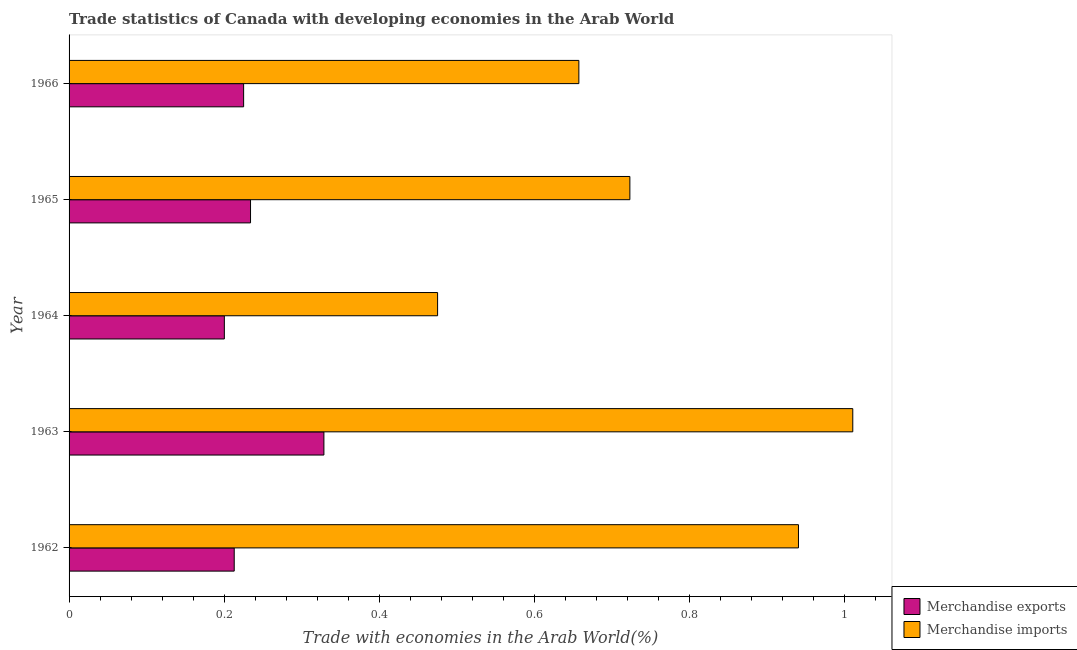How many different coloured bars are there?
Offer a very short reply. 2. Are the number of bars per tick equal to the number of legend labels?
Ensure brevity in your answer.  Yes. How many bars are there on the 2nd tick from the bottom?
Give a very brief answer. 2. What is the label of the 3rd group of bars from the top?
Ensure brevity in your answer.  1964. In how many cases, is the number of bars for a given year not equal to the number of legend labels?
Offer a terse response. 0. What is the merchandise exports in 1964?
Your answer should be very brief. 0.2. Across all years, what is the maximum merchandise imports?
Ensure brevity in your answer.  1.01. Across all years, what is the minimum merchandise exports?
Your response must be concise. 0.2. In which year was the merchandise exports minimum?
Your response must be concise. 1964. What is the total merchandise exports in the graph?
Your response must be concise. 1.2. What is the difference between the merchandise exports in 1964 and that in 1965?
Your answer should be very brief. -0.03. What is the difference between the merchandise exports in 1963 and the merchandise imports in 1965?
Offer a very short reply. -0.39. What is the average merchandise imports per year?
Your answer should be very brief. 0.76. In the year 1963, what is the difference between the merchandise exports and merchandise imports?
Ensure brevity in your answer.  -0.68. In how many years, is the merchandise exports greater than 0.48000000000000004 %?
Keep it short and to the point. 0. What is the ratio of the merchandise exports in 1964 to that in 1965?
Offer a terse response. 0.86. What is the difference between the highest and the second highest merchandise exports?
Your answer should be compact. 0.1. What is the difference between the highest and the lowest merchandise exports?
Keep it short and to the point. 0.13. In how many years, is the merchandise exports greater than the average merchandise exports taken over all years?
Your answer should be very brief. 1. What does the 2nd bar from the bottom in 1962 represents?
Make the answer very short. Merchandise imports. What is the difference between two consecutive major ticks on the X-axis?
Your response must be concise. 0.2. Are the values on the major ticks of X-axis written in scientific E-notation?
Give a very brief answer. No. What is the title of the graph?
Provide a short and direct response. Trade statistics of Canada with developing economies in the Arab World. Does "Food and tobacco" appear as one of the legend labels in the graph?
Offer a terse response. No. What is the label or title of the X-axis?
Ensure brevity in your answer.  Trade with economies in the Arab World(%). What is the label or title of the Y-axis?
Offer a terse response. Year. What is the Trade with economies in the Arab World(%) of Merchandise exports in 1962?
Make the answer very short. 0.21. What is the Trade with economies in the Arab World(%) of Merchandise imports in 1962?
Offer a terse response. 0.94. What is the Trade with economies in the Arab World(%) in Merchandise exports in 1963?
Provide a short and direct response. 0.33. What is the Trade with economies in the Arab World(%) in Merchandise imports in 1963?
Offer a very short reply. 1.01. What is the Trade with economies in the Arab World(%) of Merchandise exports in 1964?
Provide a succinct answer. 0.2. What is the Trade with economies in the Arab World(%) in Merchandise imports in 1964?
Provide a short and direct response. 0.48. What is the Trade with economies in the Arab World(%) in Merchandise exports in 1965?
Keep it short and to the point. 0.23. What is the Trade with economies in the Arab World(%) of Merchandise imports in 1965?
Your answer should be compact. 0.72. What is the Trade with economies in the Arab World(%) of Merchandise exports in 1966?
Your answer should be very brief. 0.23. What is the Trade with economies in the Arab World(%) in Merchandise imports in 1966?
Ensure brevity in your answer.  0.66. Across all years, what is the maximum Trade with economies in the Arab World(%) in Merchandise exports?
Keep it short and to the point. 0.33. Across all years, what is the maximum Trade with economies in the Arab World(%) in Merchandise imports?
Your answer should be compact. 1.01. Across all years, what is the minimum Trade with economies in the Arab World(%) in Merchandise exports?
Keep it short and to the point. 0.2. Across all years, what is the minimum Trade with economies in the Arab World(%) in Merchandise imports?
Provide a succinct answer. 0.48. What is the total Trade with economies in the Arab World(%) in Merchandise exports in the graph?
Your response must be concise. 1.2. What is the total Trade with economies in the Arab World(%) of Merchandise imports in the graph?
Your response must be concise. 3.81. What is the difference between the Trade with economies in the Arab World(%) of Merchandise exports in 1962 and that in 1963?
Give a very brief answer. -0.12. What is the difference between the Trade with economies in the Arab World(%) in Merchandise imports in 1962 and that in 1963?
Keep it short and to the point. -0.07. What is the difference between the Trade with economies in the Arab World(%) of Merchandise exports in 1962 and that in 1964?
Make the answer very short. 0.01. What is the difference between the Trade with economies in the Arab World(%) in Merchandise imports in 1962 and that in 1964?
Offer a very short reply. 0.47. What is the difference between the Trade with economies in the Arab World(%) of Merchandise exports in 1962 and that in 1965?
Your response must be concise. -0.02. What is the difference between the Trade with economies in the Arab World(%) in Merchandise imports in 1962 and that in 1965?
Give a very brief answer. 0.22. What is the difference between the Trade with economies in the Arab World(%) of Merchandise exports in 1962 and that in 1966?
Give a very brief answer. -0.01. What is the difference between the Trade with economies in the Arab World(%) in Merchandise imports in 1962 and that in 1966?
Your response must be concise. 0.28. What is the difference between the Trade with economies in the Arab World(%) in Merchandise exports in 1963 and that in 1964?
Your answer should be compact. 0.13. What is the difference between the Trade with economies in the Arab World(%) of Merchandise imports in 1963 and that in 1964?
Ensure brevity in your answer.  0.54. What is the difference between the Trade with economies in the Arab World(%) in Merchandise exports in 1963 and that in 1965?
Offer a very short reply. 0.09. What is the difference between the Trade with economies in the Arab World(%) of Merchandise imports in 1963 and that in 1965?
Keep it short and to the point. 0.29. What is the difference between the Trade with economies in the Arab World(%) of Merchandise exports in 1963 and that in 1966?
Offer a terse response. 0.1. What is the difference between the Trade with economies in the Arab World(%) in Merchandise imports in 1963 and that in 1966?
Make the answer very short. 0.35. What is the difference between the Trade with economies in the Arab World(%) in Merchandise exports in 1964 and that in 1965?
Make the answer very short. -0.03. What is the difference between the Trade with economies in the Arab World(%) in Merchandise imports in 1964 and that in 1965?
Make the answer very short. -0.25. What is the difference between the Trade with economies in the Arab World(%) of Merchandise exports in 1964 and that in 1966?
Provide a short and direct response. -0.02. What is the difference between the Trade with economies in the Arab World(%) in Merchandise imports in 1964 and that in 1966?
Ensure brevity in your answer.  -0.18. What is the difference between the Trade with economies in the Arab World(%) in Merchandise exports in 1965 and that in 1966?
Offer a very short reply. 0.01. What is the difference between the Trade with economies in the Arab World(%) of Merchandise imports in 1965 and that in 1966?
Provide a short and direct response. 0.07. What is the difference between the Trade with economies in the Arab World(%) in Merchandise exports in 1962 and the Trade with economies in the Arab World(%) in Merchandise imports in 1963?
Offer a terse response. -0.8. What is the difference between the Trade with economies in the Arab World(%) of Merchandise exports in 1962 and the Trade with economies in the Arab World(%) of Merchandise imports in 1964?
Your response must be concise. -0.26. What is the difference between the Trade with economies in the Arab World(%) in Merchandise exports in 1962 and the Trade with economies in the Arab World(%) in Merchandise imports in 1965?
Ensure brevity in your answer.  -0.51. What is the difference between the Trade with economies in the Arab World(%) in Merchandise exports in 1962 and the Trade with economies in the Arab World(%) in Merchandise imports in 1966?
Your answer should be compact. -0.44. What is the difference between the Trade with economies in the Arab World(%) in Merchandise exports in 1963 and the Trade with economies in the Arab World(%) in Merchandise imports in 1964?
Give a very brief answer. -0.15. What is the difference between the Trade with economies in the Arab World(%) in Merchandise exports in 1963 and the Trade with economies in the Arab World(%) in Merchandise imports in 1965?
Ensure brevity in your answer.  -0.39. What is the difference between the Trade with economies in the Arab World(%) in Merchandise exports in 1963 and the Trade with economies in the Arab World(%) in Merchandise imports in 1966?
Your answer should be very brief. -0.33. What is the difference between the Trade with economies in the Arab World(%) in Merchandise exports in 1964 and the Trade with economies in the Arab World(%) in Merchandise imports in 1965?
Provide a succinct answer. -0.52. What is the difference between the Trade with economies in the Arab World(%) of Merchandise exports in 1964 and the Trade with economies in the Arab World(%) of Merchandise imports in 1966?
Offer a very short reply. -0.46. What is the difference between the Trade with economies in the Arab World(%) of Merchandise exports in 1965 and the Trade with economies in the Arab World(%) of Merchandise imports in 1966?
Provide a short and direct response. -0.42. What is the average Trade with economies in the Arab World(%) in Merchandise exports per year?
Offer a very short reply. 0.24. What is the average Trade with economies in the Arab World(%) in Merchandise imports per year?
Make the answer very short. 0.76. In the year 1962, what is the difference between the Trade with economies in the Arab World(%) in Merchandise exports and Trade with economies in the Arab World(%) in Merchandise imports?
Offer a very short reply. -0.73. In the year 1963, what is the difference between the Trade with economies in the Arab World(%) of Merchandise exports and Trade with economies in the Arab World(%) of Merchandise imports?
Your response must be concise. -0.68. In the year 1964, what is the difference between the Trade with economies in the Arab World(%) in Merchandise exports and Trade with economies in the Arab World(%) in Merchandise imports?
Your answer should be compact. -0.27. In the year 1965, what is the difference between the Trade with economies in the Arab World(%) of Merchandise exports and Trade with economies in the Arab World(%) of Merchandise imports?
Ensure brevity in your answer.  -0.49. In the year 1966, what is the difference between the Trade with economies in the Arab World(%) in Merchandise exports and Trade with economies in the Arab World(%) in Merchandise imports?
Provide a short and direct response. -0.43. What is the ratio of the Trade with economies in the Arab World(%) of Merchandise exports in 1962 to that in 1963?
Keep it short and to the point. 0.65. What is the ratio of the Trade with economies in the Arab World(%) of Merchandise imports in 1962 to that in 1963?
Provide a succinct answer. 0.93. What is the ratio of the Trade with economies in the Arab World(%) of Merchandise exports in 1962 to that in 1964?
Your answer should be compact. 1.06. What is the ratio of the Trade with economies in the Arab World(%) in Merchandise imports in 1962 to that in 1964?
Your response must be concise. 1.98. What is the ratio of the Trade with economies in the Arab World(%) of Merchandise exports in 1962 to that in 1965?
Give a very brief answer. 0.91. What is the ratio of the Trade with economies in the Arab World(%) in Merchandise imports in 1962 to that in 1965?
Offer a terse response. 1.3. What is the ratio of the Trade with economies in the Arab World(%) in Merchandise exports in 1962 to that in 1966?
Your answer should be compact. 0.95. What is the ratio of the Trade with economies in the Arab World(%) in Merchandise imports in 1962 to that in 1966?
Your answer should be very brief. 1.43. What is the ratio of the Trade with economies in the Arab World(%) of Merchandise exports in 1963 to that in 1964?
Make the answer very short. 1.64. What is the ratio of the Trade with economies in the Arab World(%) in Merchandise imports in 1963 to that in 1964?
Make the answer very short. 2.13. What is the ratio of the Trade with economies in the Arab World(%) in Merchandise exports in 1963 to that in 1965?
Offer a terse response. 1.4. What is the ratio of the Trade with economies in the Arab World(%) of Merchandise imports in 1963 to that in 1965?
Your answer should be very brief. 1.4. What is the ratio of the Trade with economies in the Arab World(%) in Merchandise exports in 1963 to that in 1966?
Give a very brief answer. 1.46. What is the ratio of the Trade with economies in the Arab World(%) in Merchandise imports in 1963 to that in 1966?
Offer a very short reply. 1.54. What is the ratio of the Trade with economies in the Arab World(%) of Merchandise exports in 1964 to that in 1965?
Offer a terse response. 0.86. What is the ratio of the Trade with economies in the Arab World(%) of Merchandise imports in 1964 to that in 1965?
Keep it short and to the point. 0.66. What is the ratio of the Trade with economies in the Arab World(%) in Merchandise exports in 1964 to that in 1966?
Offer a terse response. 0.89. What is the ratio of the Trade with economies in the Arab World(%) of Merchandise imports in 1964 to that in 1966?
Provide a short and direct response. 0.72. What is the ratio of the Trade with economies in the Arab World(%) of Merchandise exports in 1965 to that in 1966?
Provide a short and direct response. 1.04. What is the ratio of the Trade with economies in the Arab World(%) in Merchandise imports in 1965 to that in 1966?
Give a very brief answer. 1.1. What is the difference between the highest and the second highest Trade with economies in the Arab World(%) in Merchandise exports?
Provide a short and direct response. 0.09. What is the difference between the highest and the second highest Trade with economies in the Arab World(%) in Merchandise imports?
Provide a succinct answer. 0.07. What is the difference between the highest and the lowest Trade with economies in the Arab World(%) in Merchandise exports?
Provide a succinct answer. 0.13. What is the difference between the highest and the lowest Trade with economies in the Arab World(%) in Merchandise imports?
Make the answer very short. 0.54. 